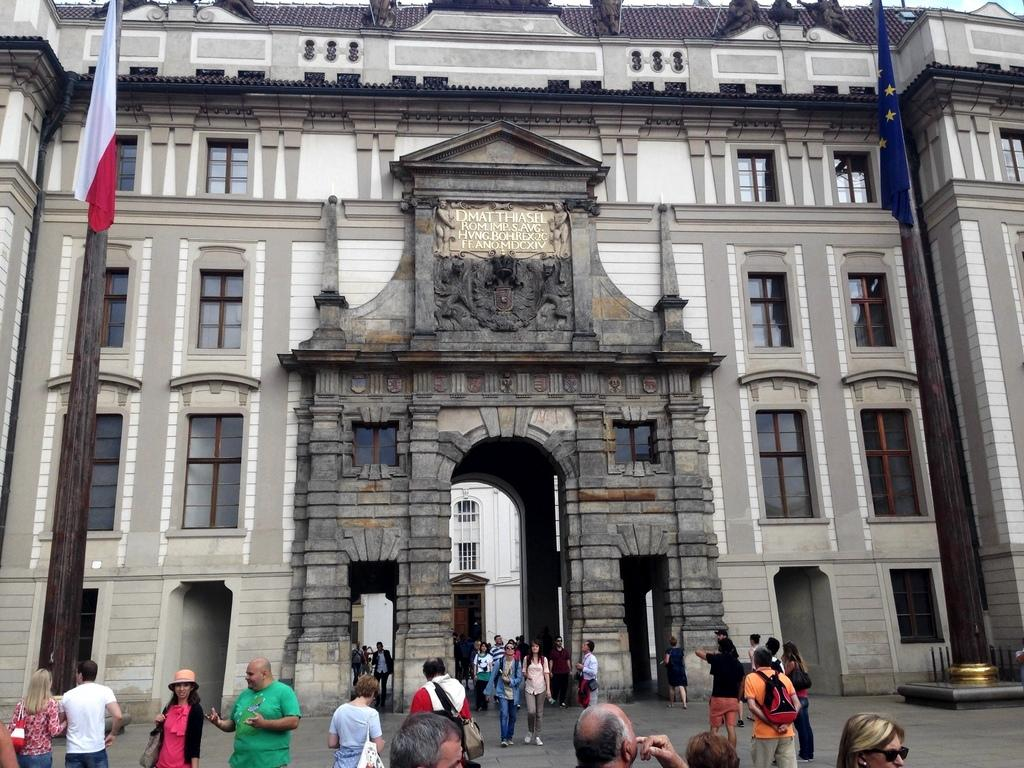What objects can be seen in the image? There are bags and caps in the image. What are the people in the image doing? There is a group of people standing in the image, and some people are walking on the ground. What can be seen in the background of the image? There are poles, flags, buildings, windows, and an arch in the background of the image. What historical event is being commemorated by the judge in the image? There is no judge present in the image, and no historical event is being commemorated. How many quarters are visible in the image? There are no quarters visible in the image. 